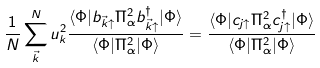<formula> <loc_0><loc_0><loc_500><loc_500>\frac { 1 } { N } \sum _ { \vec { k } } ^ { N } u _ { k } ^ { 2 } \frac { \langle \Phi | b _ { { \vec { k } } \uparrow } \Pi _ { \alpha } ^ { 2 } b _ { { \vec { k } } \uparrow } ^ { \dagger } | \Phi \rangle } { \langle \Phi | \Pi _ { \alpha } ^ { 2 } | \Phi \rangle } = \frac { \langle \Phi | c _ { j \uparrow } \Pi _ { \alpha } ^ { 2 } c _ { j \uparrow } ^ { \dagger } | \Phi \rangle } { \langle \Phi | \Pi _ { \alpha } ^ { 2 } | \Phi \rangle }</formula> 